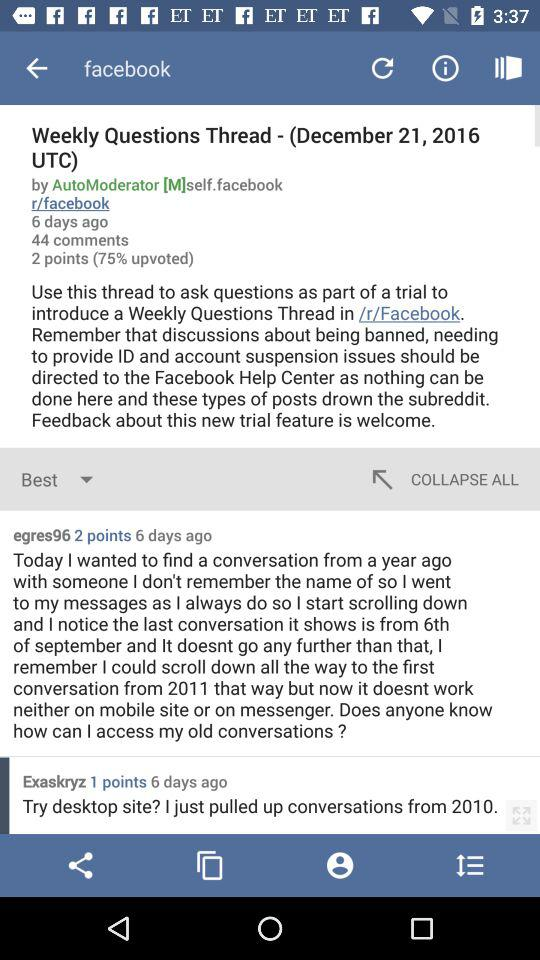How many comments are there in this post?
Answer the question using a single word or phrase. 44 